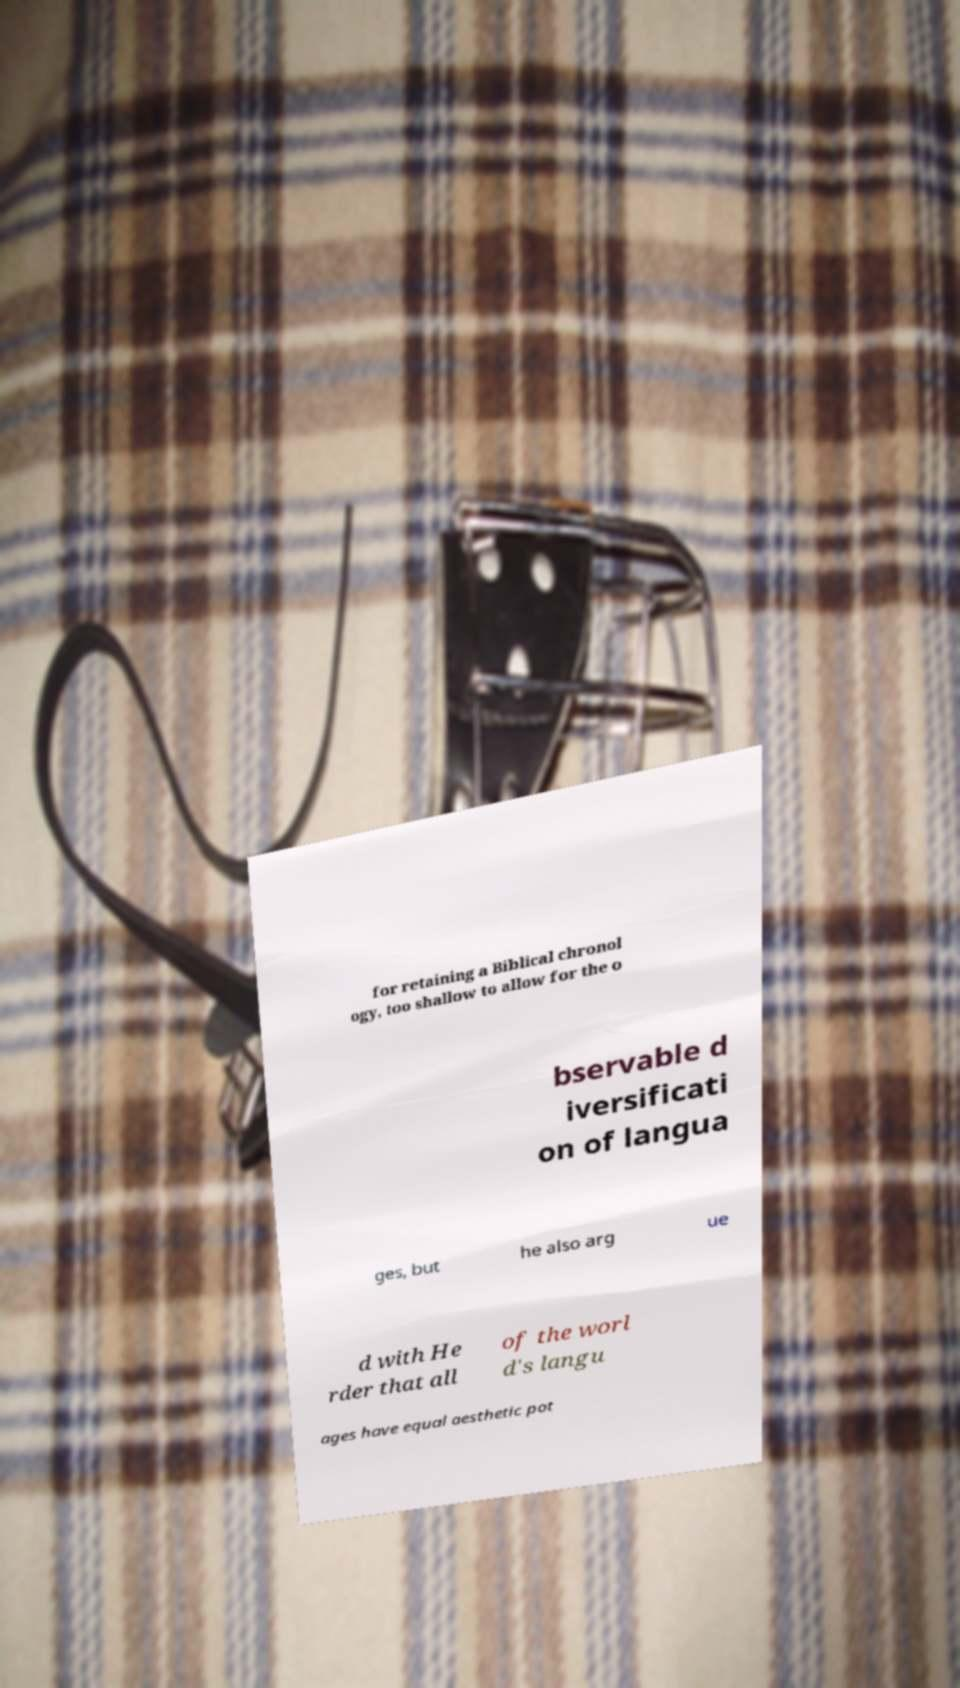There's text embedded in this image that I need extracted. Can you transcribe it verbatim? for retaining a Biblical chronol ogy, too shallow to allow for the o bservable d iversificati on of langua ges, but he also arg ue d with He rder that all of the worl d's langu ages have equal aesthetic pot 